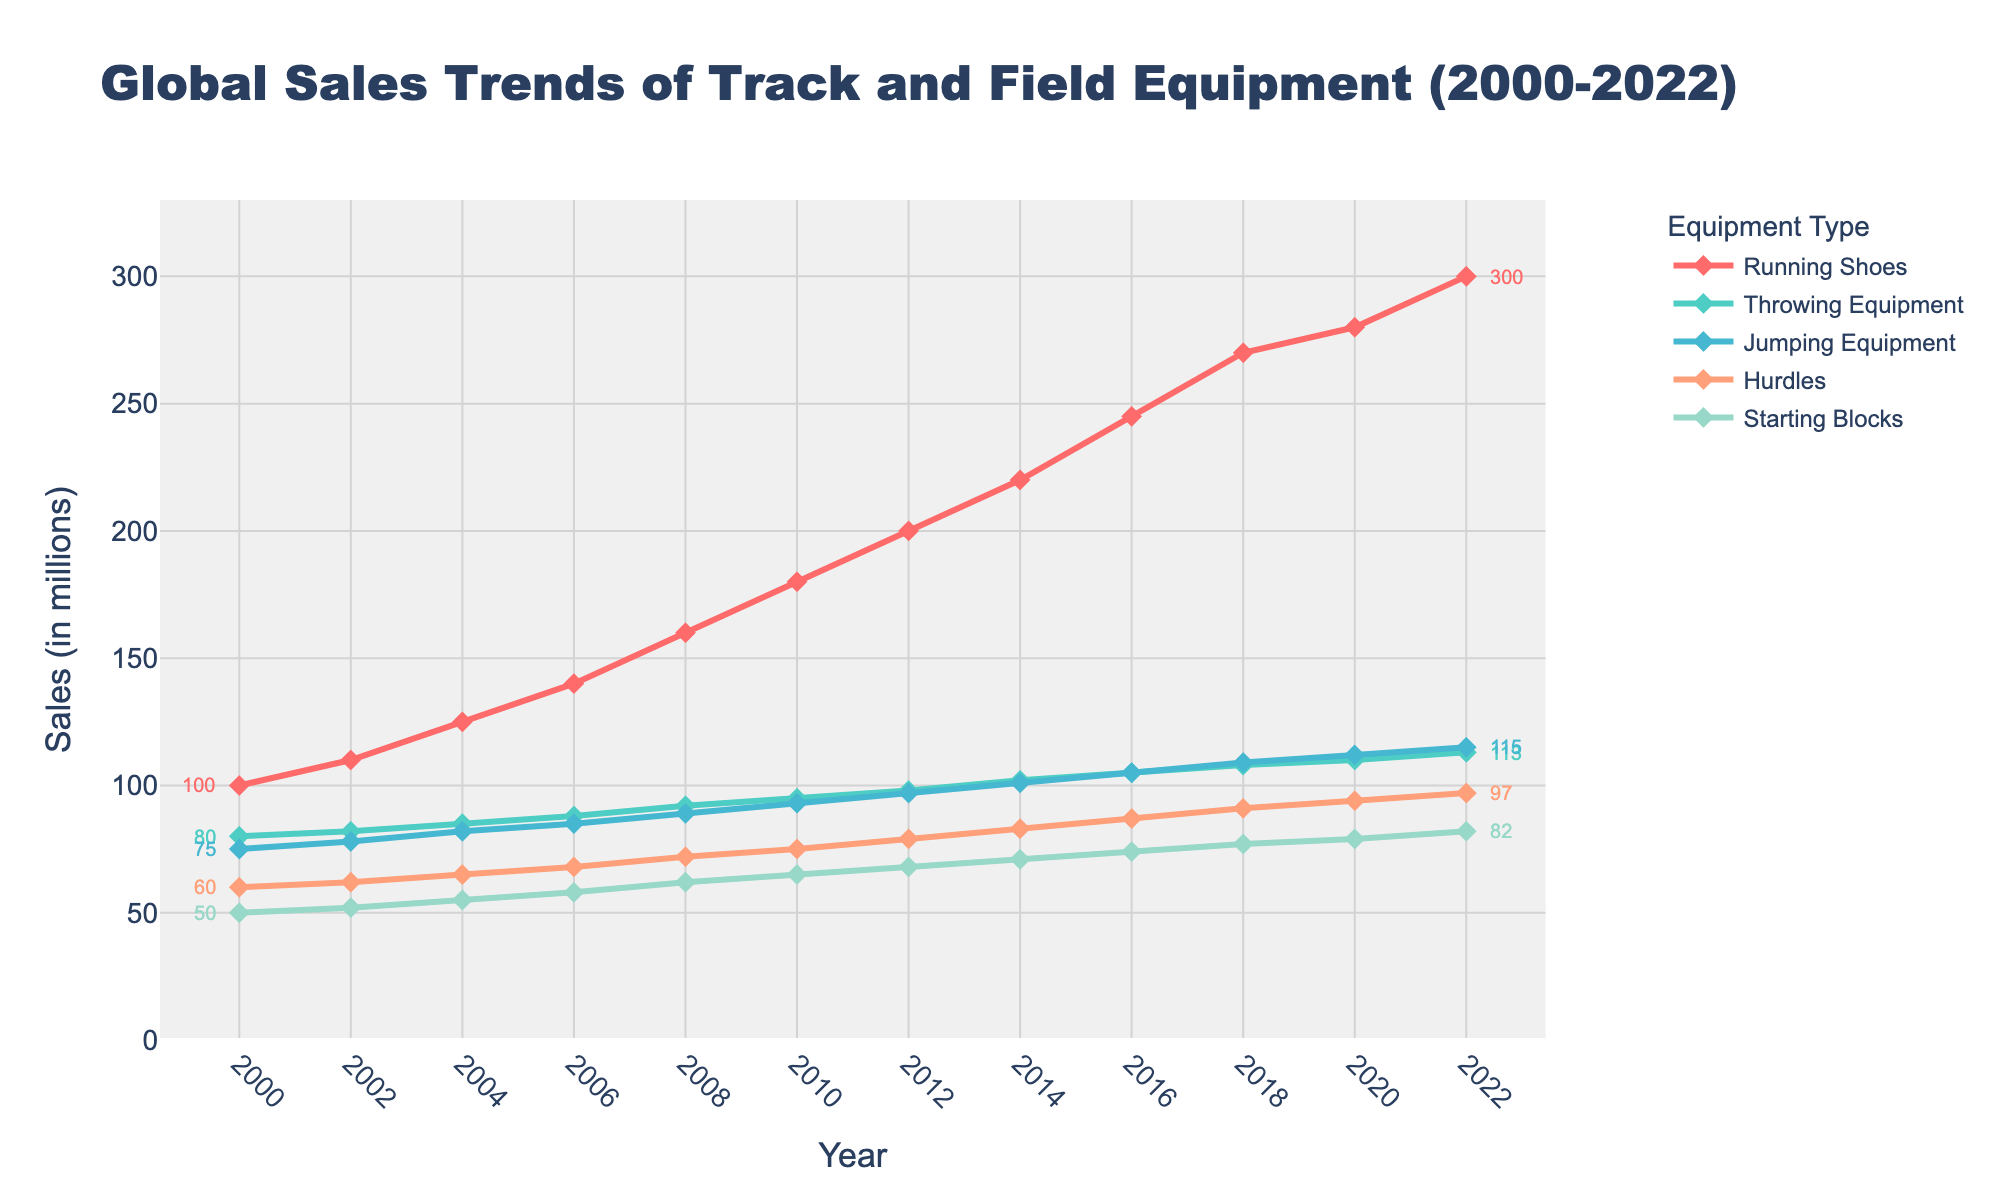How did the sales of Running Shoes change from 2002 to 2010? The sales of Running Shoes in 2002 were 110 and in 2010 were 180. To find the change, subtract the 2002 value from the 2010 value: 180 - 110 = 70.
Answer: 70 Which product type showed the highest increase in sales from 2000 to 2022? Calculate the difference in sales for each product type between 2000 and 2022. Running Shoes: 300 - 100 = 200, Throwing Equipment: 113 - 80 = 33, Jumping Equipment: 115 - 75 = 40, Hurdles: 97 - 60 = 37, Starting Blocks: 82 - 50 = 32. Running Shoes showed the highest increase of 200.
Answer: Running Shoes During which period did Throwing Equipment sales increase the most rapidly? Observe the slope of the line representing Throwing Equipment sales and identify the period with the steepest increase. Between 2000 and 2006, the sales increased from 80 to 88 (8 units over 6 years), which is less steep than the period 2010 to 2022 where the sales increased from 95 to 113 (18 units over 12 years). But the steepest growth is observed between 2018 and 2020 where sales went from 108 to 110 (2 units over 2 years).
Answer: 2018-2020 What was the sales difference between Jumping Equipment and Starting Blocks in 2014? Jumping Equipment sales in 2014 were 101, and Starting Blocks sales were 71. Subtract Starting Blocks sales from Jumping Equipment sales: 101 - 71 = 30.
Answer: 30 In which year did Hurdles sales surpass 80 for the first time? Check the data for Hurdles sales data to locate the year when the value first exceeds 80. Hurdles sales were 83 in 2014.
Answer: 2014 How many years did it take for the sales of Running Shoes to double from their 2000 value? The sales of Running Shoes in 2000 were 100, and they doubled to 200. Check the data to find the first year when sales reached or exceeded 200, which is 2012. Subtract 2000 from 2012: 2012 - 2000 = 12 years.
Answer: 12 years Which product type had the smallest increase in sales from 2020 to 2022? Calculate the increase for each product type between 2020 and 2022. Running Shoes: 300 - 280 = 20, Throwing Equipment: 113 - 110 = 3, Jumping Equipment: 115 - 112 = 3, Hurdles: 97 - 94 = 3, Starting Blocks: 82 - 79 = 3. All except Running Shoes had an increase of 3, thus any of these could be chosen.
Answer: Throwing Equipment/Jumping Equipment/Hurdles/Starting Blocks If you want to compare the growth trends of Starting Blocks and Hurdles, which showed a faster growth rate overall? Calculate the total increase and the number of years over the entire period for each product. Starting Blocks increased from 50 to 82 over 22 years, which is 32 units. Hurdles increased from 60 to 97, which is 37 units. Hurdles had a higher total increase.
Answer: Hurdles Which product had the highest sales in the year 2016? Check the sales data for all products in 2016. Running Shoes: 245, Throwing Equipment: 105, Jumping Equipment: 105, Hurdles: 87, Starting Blocks: 74. Running Shoes had the highest sales.
Answer: Running Shoes 